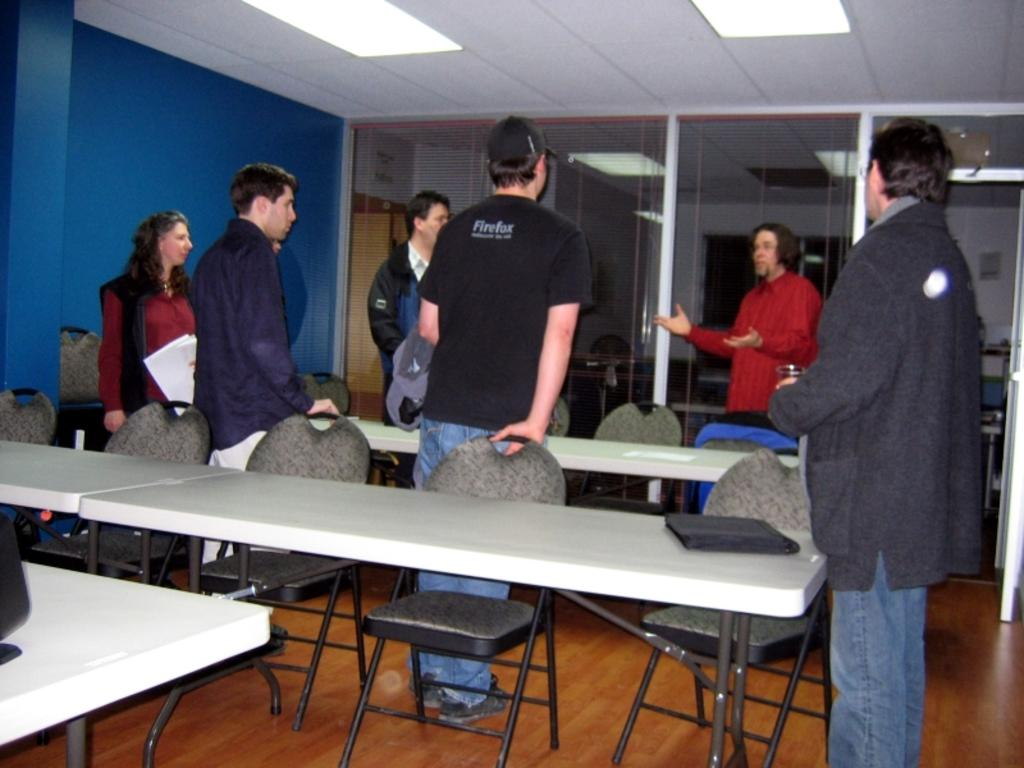What are the people in the image doing? There is a group of people standing and talking in the image. What is the woman holding? The woman is holding a paper. How many chairs are visible in the image? There are empty chairs visible in the image. What is on the table in the image? There is a file placed on the table. Where does the scene appear to take place? The scene appears to be inside a room. How does the woman's knee affect the group's fight in the image? There is no fight or mention of a knee in the image; it features a group of people standing and talking, with a woman holding a paper and a table with a file on it. 